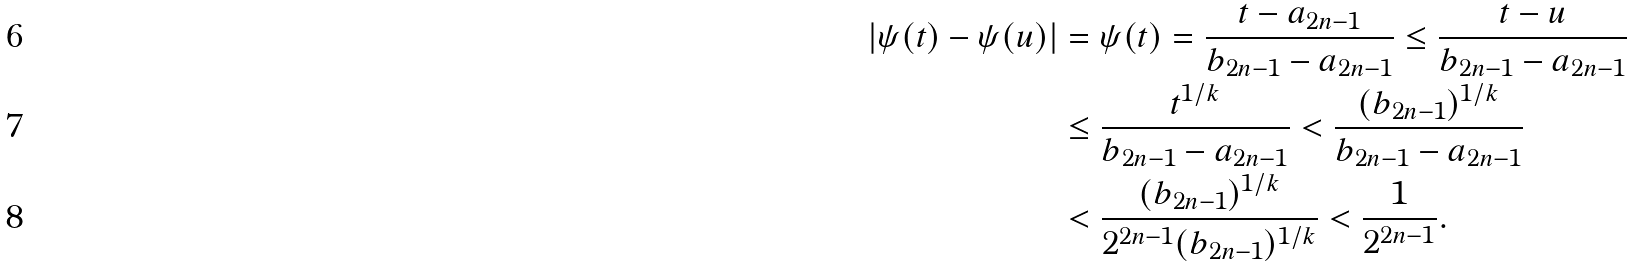Convert formula to latex. <formula><loc_0><loc_0><loc_500><loc_500>| \psi ( t ) - \psi ( u ) | & = \psi ( t ) = \frac { t - a _ { 2 n - 1 } } { b _ { 2 n - 1 } - a _ { 2 n - 1 } } \leq \frac { t - u } { b _ { 2 n - 1 } - a _ { 2 n - 1 } } \\ & \leq \frac { t ^ { 1 / k } } { b _ { 2 n - 1 } - a _ { 2 n - 1 } } < \frac { ( b _ { 2 n - 1 } ) ^ { 1 / k } } { b _ { 2 n - 1 } - a _ { 2 n - 1 } } \\ & < \frac { ( b _ { 2 n - 1 } ) ^ { 1 / k } } { 2 ^ { 2 n - 1 } ( b _ { 2 n - 1 } ) ^ { 1 / k } } < \frac { 1 } { 2 ^ { 2 n - 1 } } .</formula> 